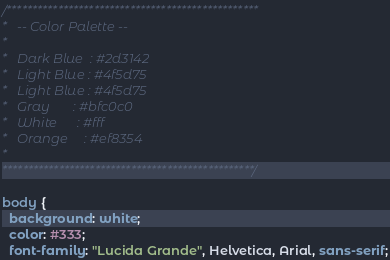Convert code to text. <code><loc_0><loc_0><loc_500><loc_500><_CSS_>/*************************************************
*   -- Color Palette --
*
*   Dark Blue  : #2d3142
*   Light Blue : #4f5d75
*   Light Blue : #4f5d75
*   Gray       : #bfc0c0
*   White      : #fff
*   Orange     : #ef8354
*
*************************************************/

body {
  background: white;
  color: #333;
  font-family: "Lucida Grande", Helvetica, Arial, sans-serif;</code> 